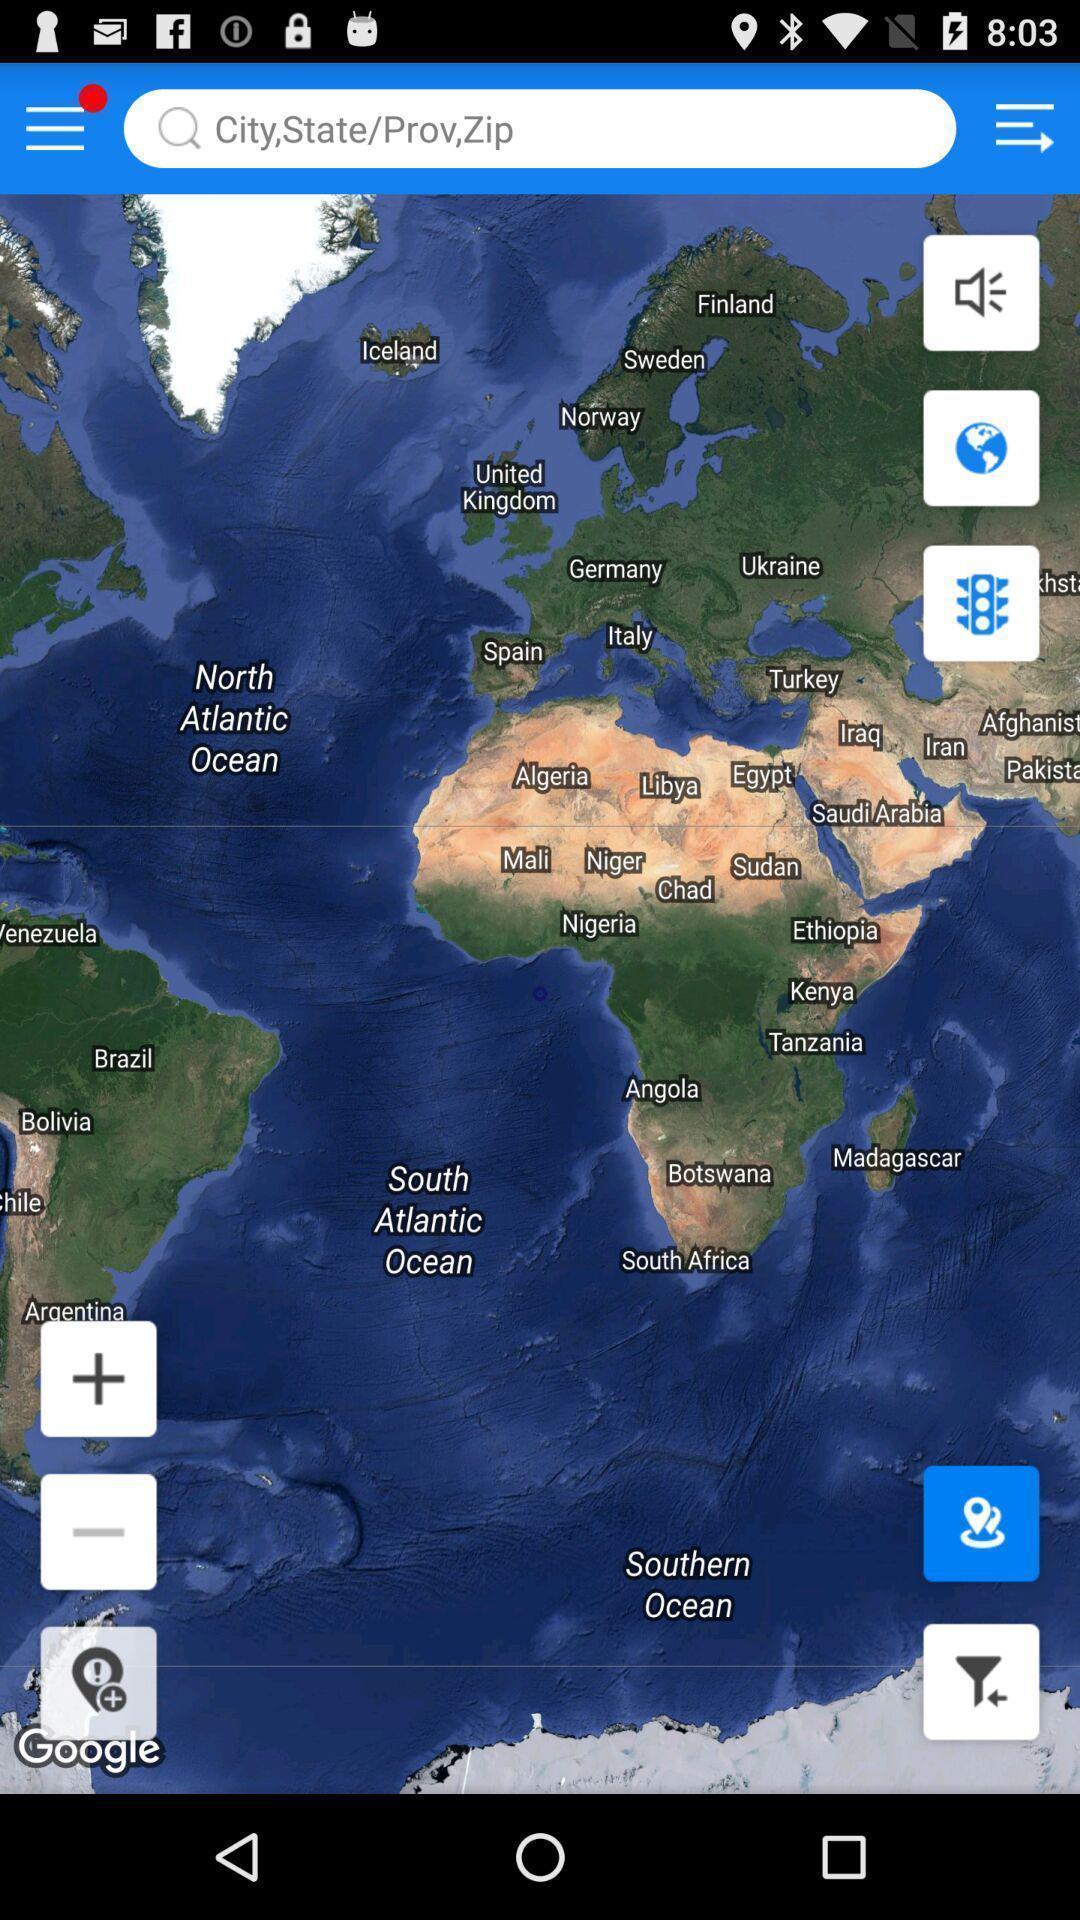Provide a detailed account of this screenshot. Page showing different options in the location finding app. 